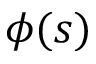Convert formula to latex. <formula><loc_0><loc_0><loc_500><loc_500>\phi ( s )</formula> 